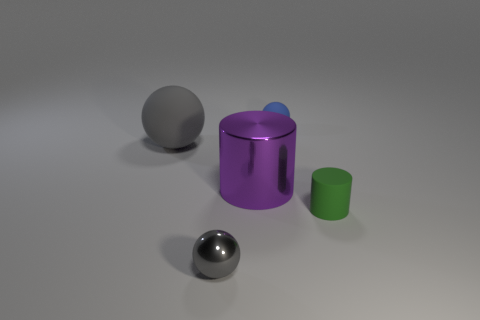How many gray balls must be subtracted to get 1 gray balls? 1 Subtract all gray balls. How many balls are left? 1 Add 4 small gray shiny cylinders. How many objects exist? 9 Subtract all purple cubes. How many gray balls are left? 2 Subtract all blue balls. How many balls are left? 2 Subtract all spheres. How many objects are left? 2 Subtract 0 red cylinders. How many objects are left? 5 Subtract 1 cylinders. How many cylinders are left? 1 Subtract all yellow cylinders. Subtract all brown balls. How many cylinders are left? 2 Subtract all large balls. Subtract all shiny objects. How many objects are left? 2 